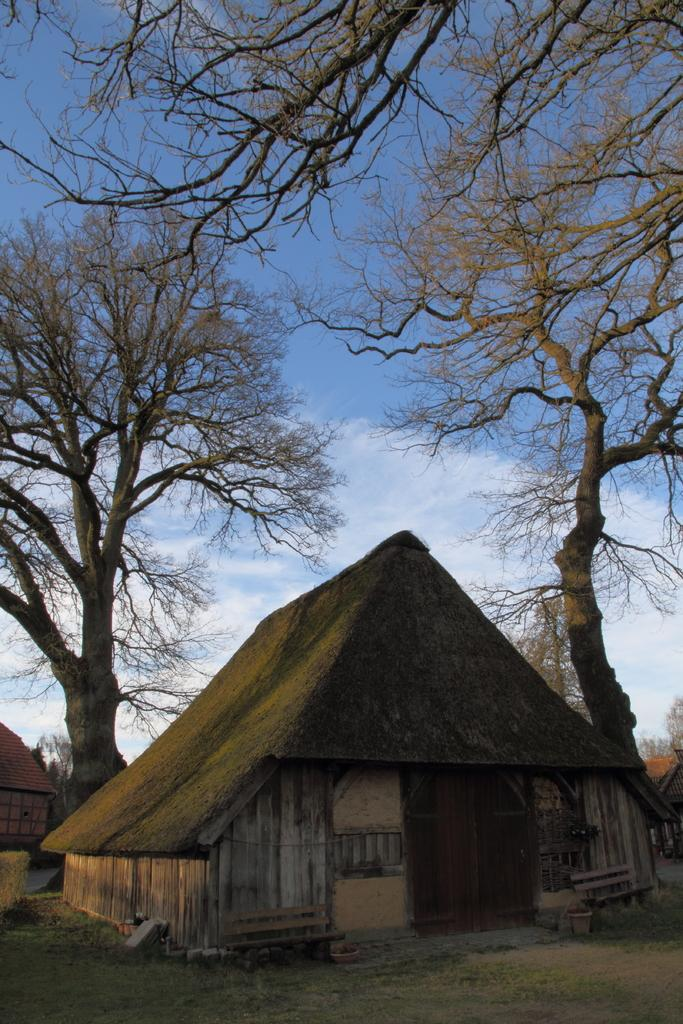What type of structure is in the image? There is a hut in the image. What can be seen on the left side of the image? There are trees on the left side of the image. What can be seen on the right side of the image? There are trees on the right side of the image. What is visible in the background of the image? The sky is visible in the background of the image. Where is the crook being held in the image? There is no crook present in the image. Is the jail visible in the image? There is no jail present in the image. 